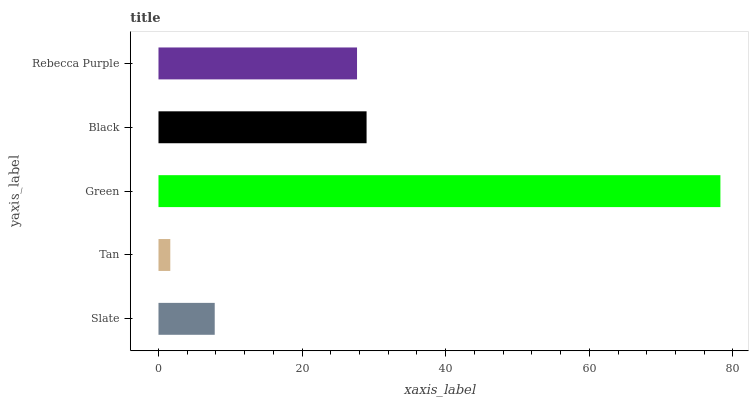Is Tan the minimum?
Answer yes or no. Yes. Is Green the maximum?
Answer yes or no. Yes. Is Green the minimum?
Answer yes or no. No. Is Tan the maximum?
Answer yes or no. No. Is Green greater than Tan?
Answer yes or no. Yes. Is Tan less than Green?
Answer yes or no. Yes. Is Tan greater than Green?
Answer yes or no. No. Is Green less than Tan?
Answer yes or no. No. Is Rebecca Purple the high median?
Answer yes or no. Yes. Is Rebecca Purple the low median?
Answer yes or no. Yes. Is Slate the high median?
Answer yes or no. No. Is Tan the low median?
Answer yes or no. No. 